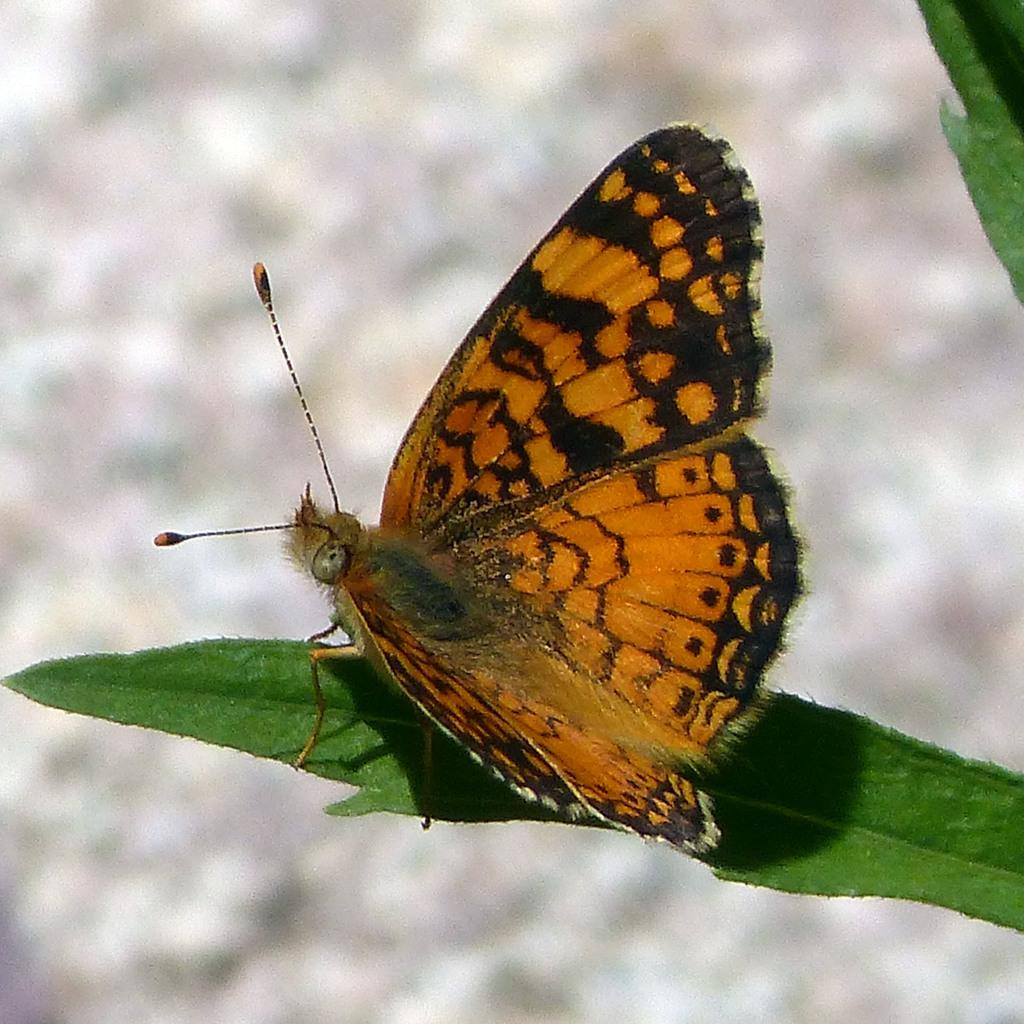What is the main subject of the image? There is a butterfly in the image. Where is the butterfly located? The butterfly is on a leaf. Are there any other leaves visible in the image? Yes, there is another leaf visible in the top right of the image. How would you describe the background of the image? The background of the image is blurred. What time is displayed on the clock in the image? There is no clock present in the image, so it is not possible to determine the time. 